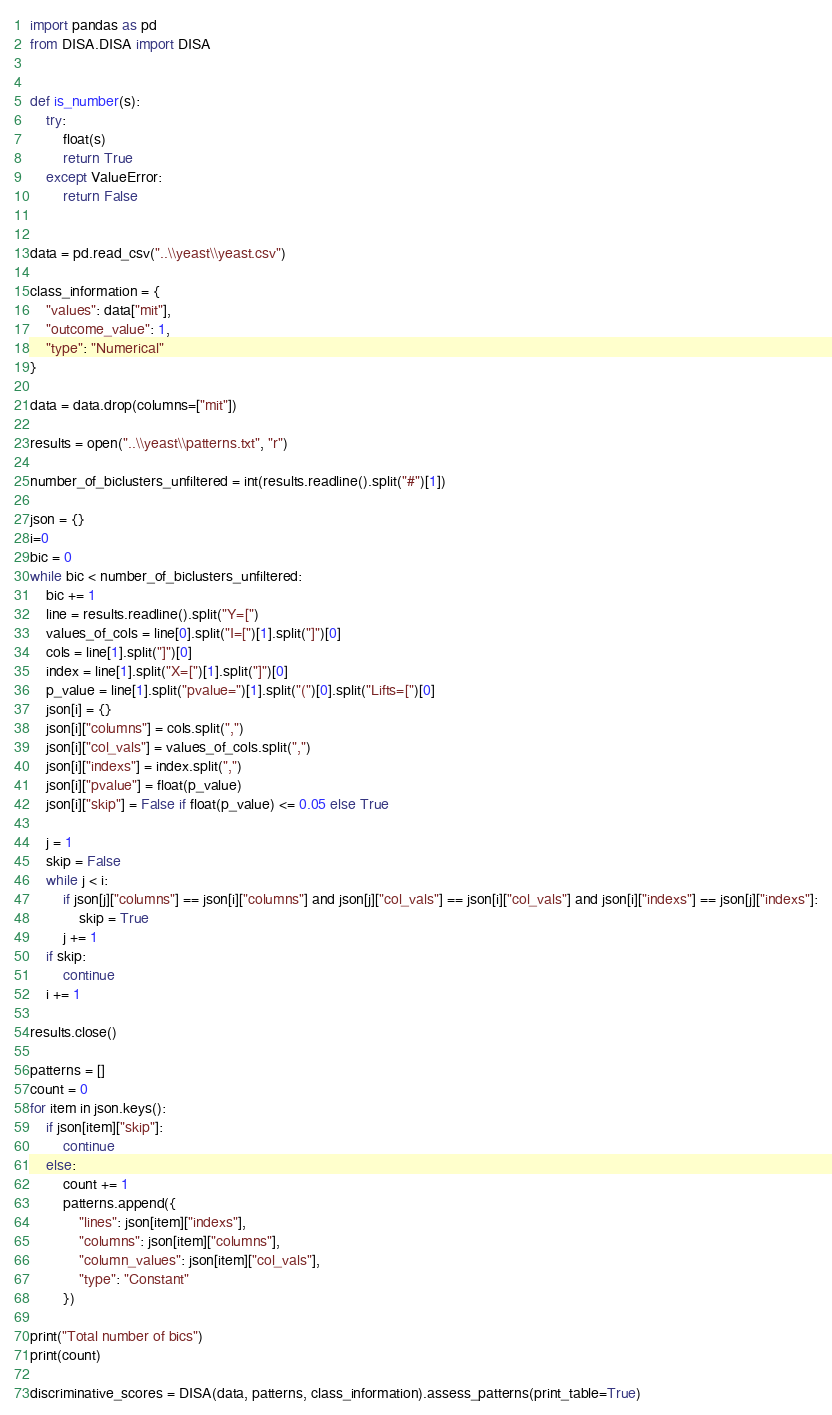Convert code to text. <code><loc_0><loc_0><loc_500><loc_500><_Python_>import pandas as pd
from DISA.DISA import DISA


def is_number(s):
    try:
        float(s)
        return True
    except ValueError:
        return False


data = pd.read_csv("..\\yeast\\yeast.csv")

class_information = {
    "values": data["mit"],
    "outcome_value": 1,
    "type": "Numerical"
}

data = data.drop(columns=["mit"])

results = open("..\\yeast\\patterns.txt", "r")

number_of_biclusters_unfiltered = int(results.readline().split("#")[1])

json = {}
i=0
bic = 0
while bic < number_of_biclusters_unfiltered:
    bic += 1
    line = results.readline().split("Y=[")
    values_of_cols = line[0].split("I=[")[1].split("]")[0]
    cols = line[1].split("]")[0]
    index = line[1].split("X=[")[1].split("]")[0]
    p_value = line[1].split("pvalue=")[1].split("(")[0].split("Lifts=[")[0]
    json[i] = {}
    json[i]["columns"] = cols.split(",")
    json[i]["col_vals"] = values_of_cols.split(",")
    json[i]["indexs"] = index.split(",")
    json[i]["pvalue"] = float(p_value)
    json[i]["skip"] = False if float(p_value) <= 0.05 else True

    j = 1
    skip = False
    while j < i:
        if json[j]["columns"] == json[i]["columns"] and json[j]["col_vals"] == json[i]["col_vals"] and json[i]["indexs"] == json[j]["indexs"]:
            skip = True
        j += 1
    if skip:
        continue
    i += 1

results.close()

patterns = []
count = 0
for item in json.keys():
    if json[item]["skip"]:
        continue
    else:
        count += 1
        patterns.append({
            "lines": json[item]["indexs"],
            "columns": json[item]["columns"],
            "column_values": json[item]["col_vals"],
            "type": "Constant"
        })

print("Total number of bics")
print(count)

discriminative_scores = DISA(data, patterns, class_information).assess_patterns(print_table=True)
</code> 